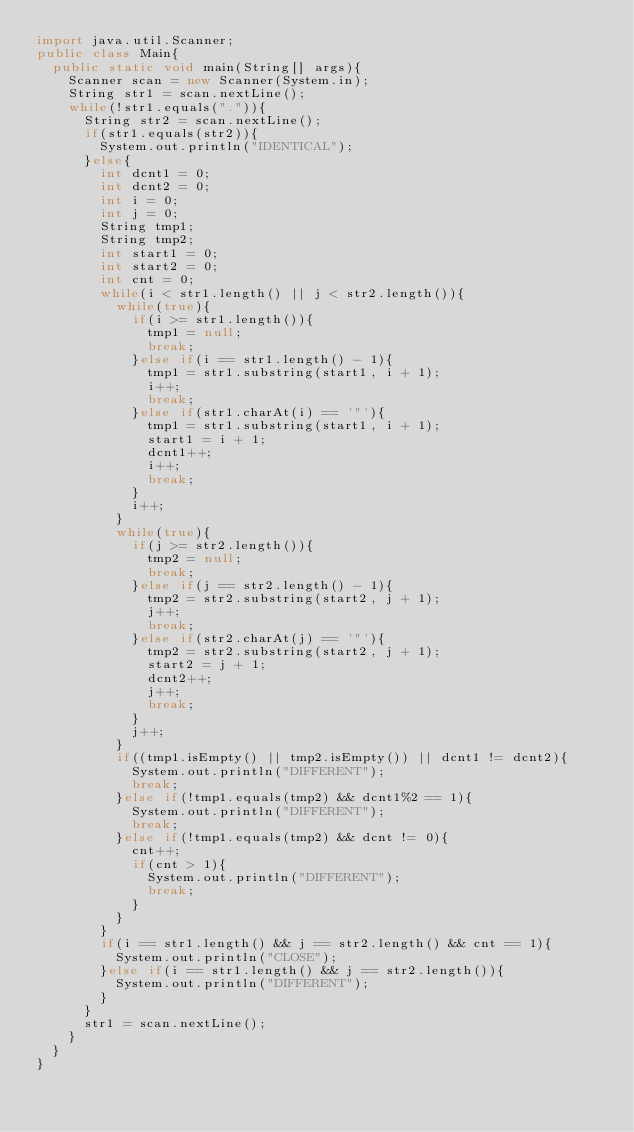<code> <loc_0><loc_0><loc_500><loc_500><_Java_>import java.util.Scanner;
public class Main{
	public static void main(String[] args){
		Scanner scan = new Scanner(System.in);
		String str1 = scan.nextLine();
		while(!str1.equals(".")){
			String str2 = scan.nextLine();
			if(str1.equals(str2)){
				System.out.println("IDENTICAL");
			}else{
				int dcnt1 = 0;
				int dcnt2 = 0;
				int i = 0;
				int j = 0;
				String tmp1;
				String tmp2;
				int start1 = 0;
				int start2 = 0;
				int cnt = 0;
				while(i < str1.length() || j < str2.length()){
					while(true){
						if(i >= str1.length()){
							tmp1 = null;
							break;
						}else if(i == str1.length() - 1){
							tmp1 = str1.substring(start1, i + 1);
							i++;
							break;
						}else if(str1.charAt(i) == '"'){
							tmp1 = str1.substring(start1, i + 1);
							start1 = i + 1;
							dcnt1++;
							i++;
							break;
						}
						i++;
					}
					while(true){
						if(j >= str2.length()){
							tmp2 = null;
							break;
						}else if(j == str2.length() - 1){
							tmp2 = str2.substring(start2, j + 1);
							j++;
							break;
						}else if(str2.charAt(j) == '"'){
							tmp2 = str2.substring(start2, j + 1);
							start2 = j + 1;
							dcnt2++;
							j++;
							break;
						}
						j++;
					}
					if((tmp1.isEmpty() || tmp2.isEmpty()) || dcnt1 != dcnt2){
						System.out.println("DIFFERENT");
						break;
					}else if(!tmp1.equals(tmp2) && dcnt1%2 == 1){
						System.out.println("DIFFERENT");
						break;
					}else if(!tmp1.equals(tmp2) && dcnt != 0){
						cnt++;
						if(cnt > 1){
							System.out.println("DIFFERENT");
							break;
						}
					}
				}
				if(i == str1.length() && j == str2.length() && cnt == 1){
					System.out.println("CLOSE");
				}else if(i == str1.length() && j == str2.length()){
					System.out.println("DIFFERENT");
				}
			}
			str1 = scan.nextLine();
		}
	}
}
</code> 